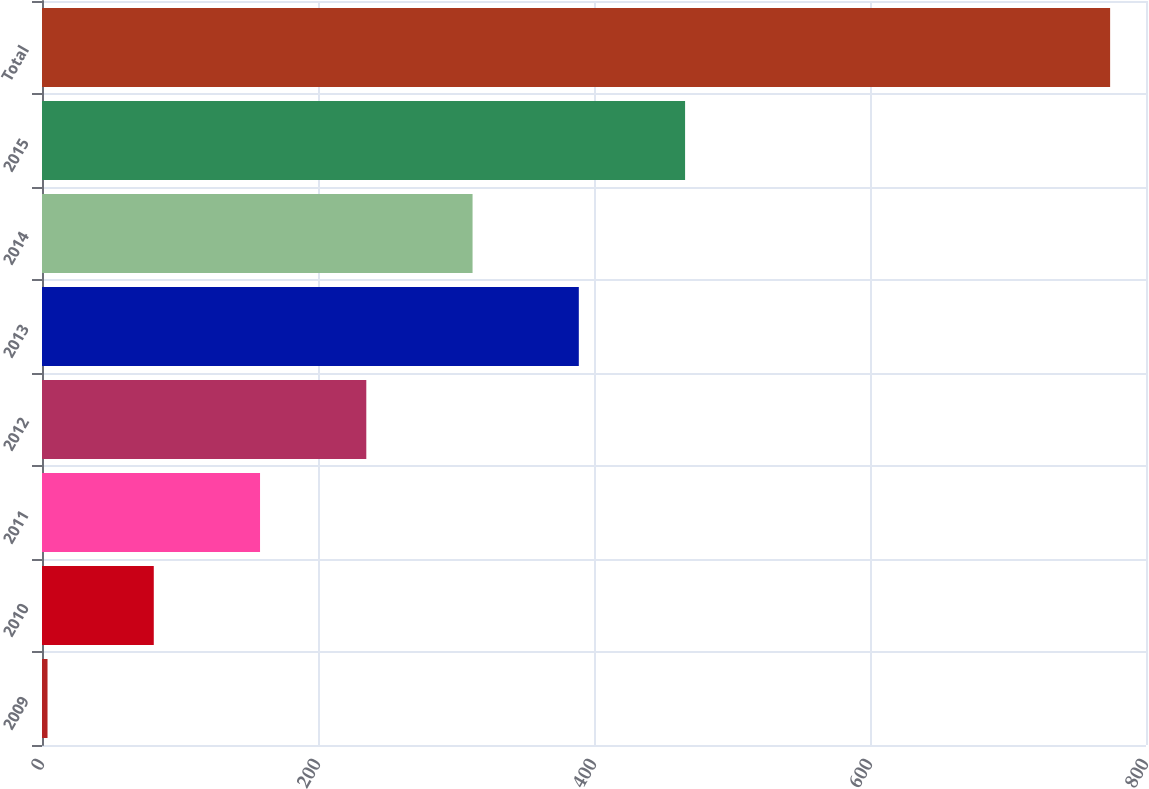<chart> <loc_0><loc_0><loc_500><loc_500><bar_chart><fcel>2009<fcel>2010<fcel>2011<fcel>2012<fcel>2013<fcel>2014<fcel>2015<fcel>Total<nl><fcel>4<fcel>81<fcel>158<fcel>235<fcel>389<fcel>312<fcel>466<fcel>774<nl></chart> 